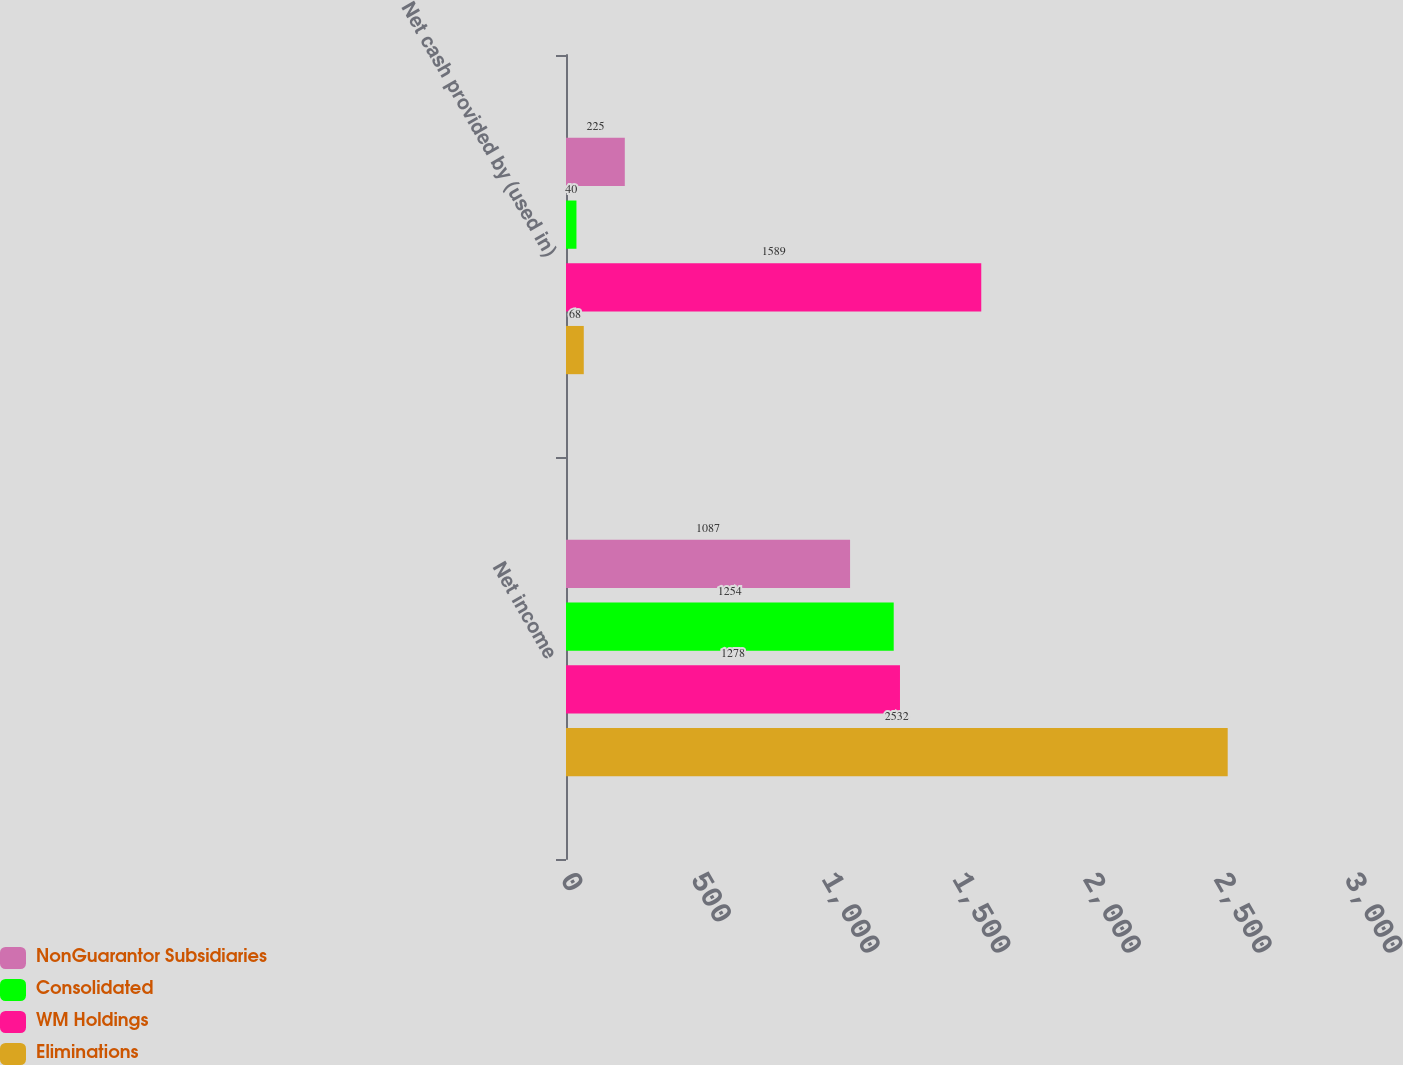<chart> <loc_0><loc_0><loc_500><loc_500><stacked_bar_chart><ecel><fcel>Net income<fcel>Net cash provided by (used in)<nl><fcel>NonGuarantor Subsidiaries<fcel>1087<fcel>225<nl><fcel>Consolidated<fcel>1254<fcel>40<nl><fcel>WM Holdings<fcel>1278<fcel>1589<nl><fcel>Eliminations<fcel>2532<fcel>68<nl></chart> 